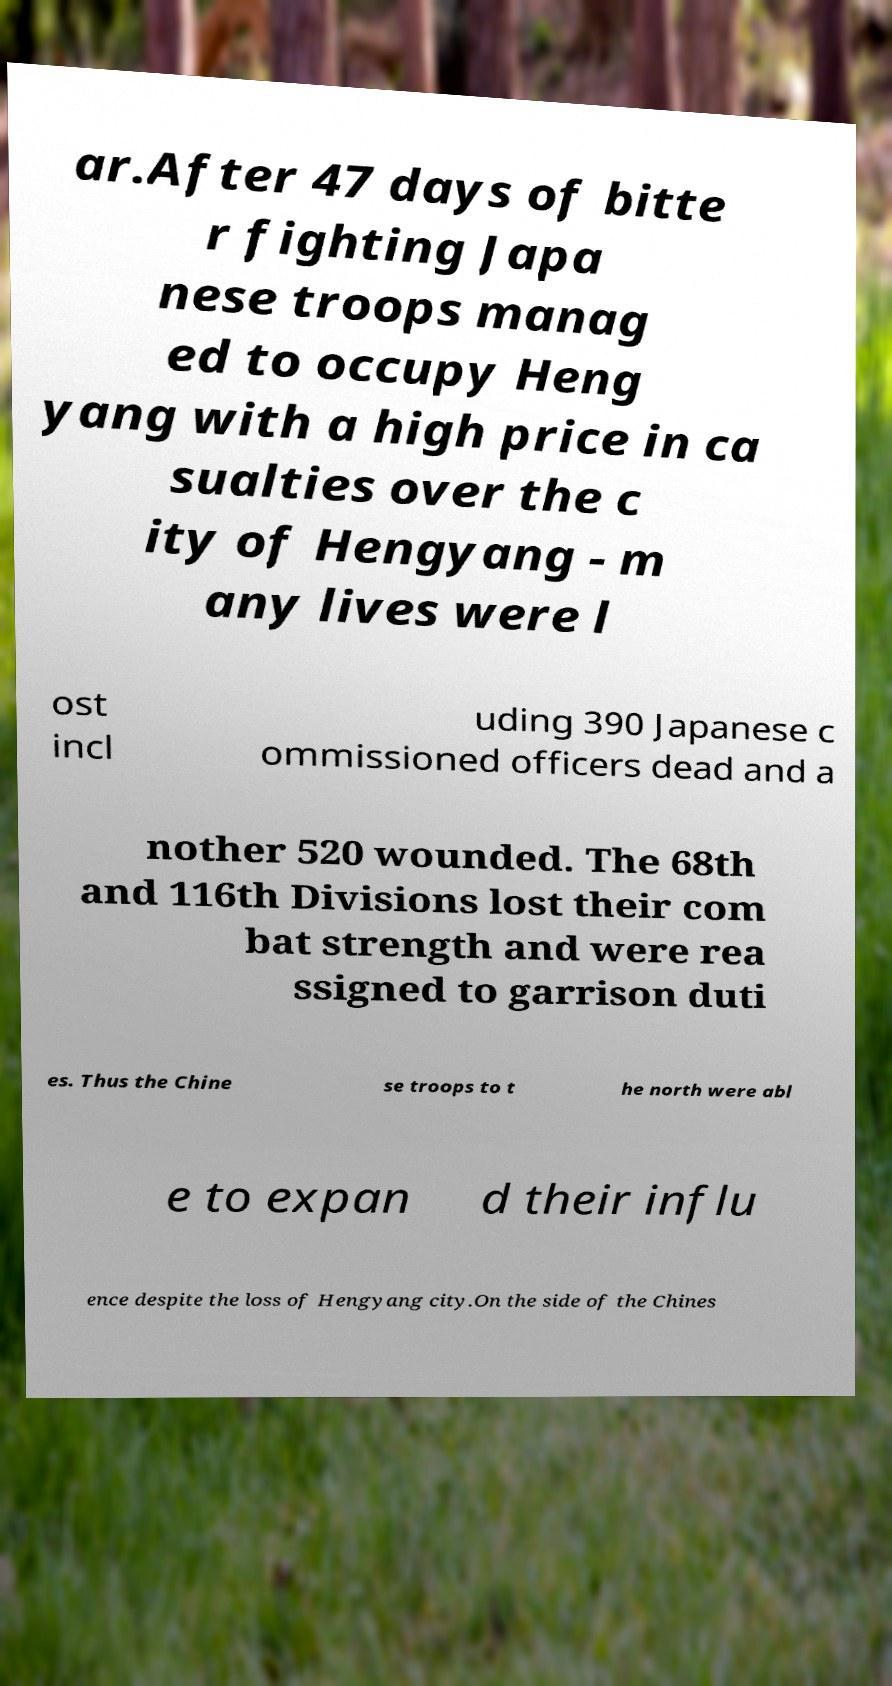Could you assist in decoding the text presented in this image and type it out clearly? ar.After 47 days of bitte r fighting Japa nese troops manag ed to occupy Heng yang with a high price in ca sualties over the c ity of Hengyang - m any lives were l ost incl uding 390 Japanese c ommissioned officers dead and a nother 520 wounded. The 68th and 116th Divisions lost their com bat strength and were rea ssigned to garrison duti es. Thus the Chine se troops to t he north were abl e to expan d their influ ence despite the loss of Hengyang city.On the side of the Chines 